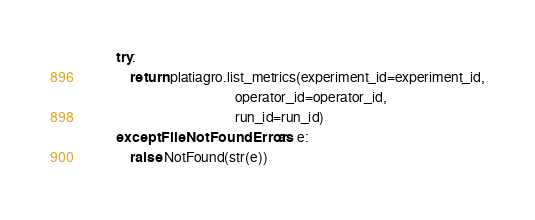Convert code to text. <code><loc_0><loc_0><loc_500><loc_500><_Python_>        try:
            return platiagro.list_metrics(experiment_id=experiment_id,
                                          operator_id=operator_id,
                                          run_id=run_id)
        except FileNotFoundError as e:
            raise NotFound(str(e))
</code> 